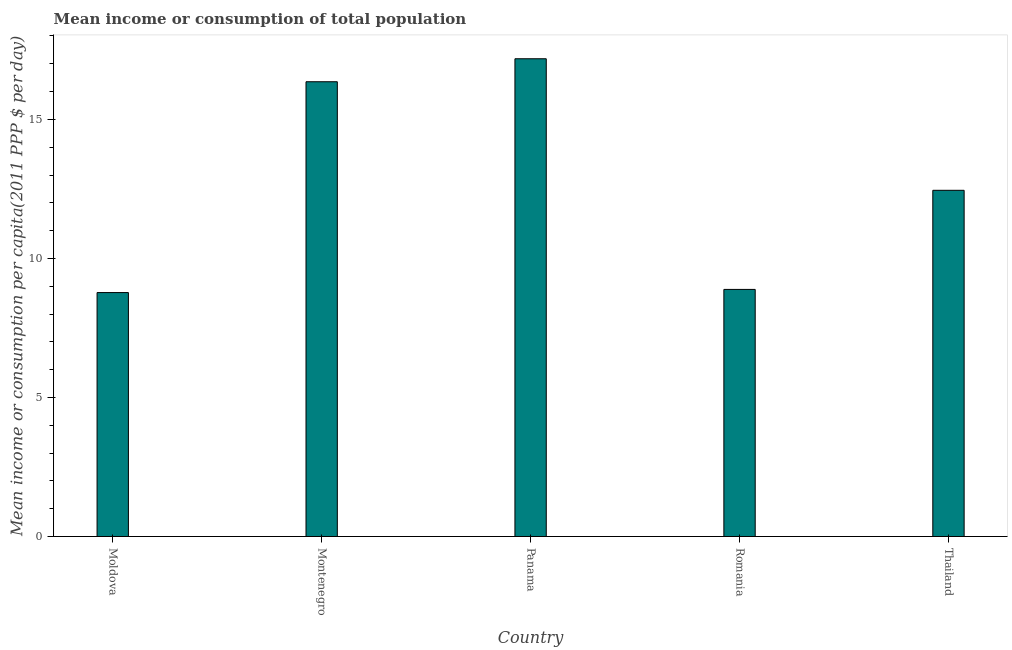Does the graph contain any zero values?
Your response must be concise. No. What is the title of the graph?
Your response must be concise. Mean income or consumption of total population. What is the label or title of the X-axis?
Offer a very short reply. Country. What is the label or title of the Y-axis?
Offer a terse response. Mean income or consumption per capita(2011 PPP $ per day). What is the mean income or consumption in Montenegro?
Give a very brief answer. 16.35. Across all countries, what is the maximum mean income or consumption?
Your answer should be very brief. 17.18. Across all countries, what is the minimum mean income or consumption?
Provide a succinct answer. 8.77. In which country was the mean income or consumption maximum?
Give a very brief answer. Panama. In which country was the mean income or consumption minimum?
Ensure brevity in your answer.  Moldova. What is the sum of the mean income or consumption?
Provide a succinct answer. 63.65. What is the difference between the mean income or consumption in Panama and Romania?
Make the answer very short. 8.29. What is the average mean income or consumption per country?
Give a very brief answer. 12.73. What is the median mean income or consumption?
Give a very brief answer. 12.45. In how many countries, is the mean income or consumption greater than 7 $?
Ensure brevity in your answer.  5. What is the ratio of the mean income or consumption in Moldova to that in Panama?
Your answer should be compact. 0.51. Is the difference between the mean income or consumption in Panama and Thailand greater than the difference between any two countries?
Give a very brief answer. No. What is the difference between the highest and the second highest mean income or consumption?
Ensure brevity in your answer.  0.83. What is the difference between the highest and the lowest mean income or consumption?
Offer a very short reply. 8.41. How many bars are there?
Provide a short and direct response. 5. Are all the bars in the graph horizontal?
Make the answer very short. No. How many countries are there in the graph?
Give a very brief answer. 5. Are the values on the major ticks of Y-axis written in scientific E-notation?
Offer a terse response. No. What is the Mean income or consumption per capita(2011 PPP $ per day) in Moldova?
Make the answer very short. 8.77. What is the Mean income or consumption per capita(2011 PPP $ per day) in Montenegro?
Give a very brief answer. 16.35. What is the Mean income or consumption per capita(2011 PPP $ per day) of Panama?
Provide a short and direct response. 17.18. What is the Mean income or consumption per capita(2011 PPP $ per day) of Romania?
Offer a terse response. 8.89. What is the Mean income or consumption per capita(2011 PPP $ per day) in Thailand?
Make the answer very short. 12.45. What is the difference between the Mean income or consumption per capita(2011 PPP $ per day) in Moldova and Montenegro?
Your answer should be compact. -7.58. What is the difference between the Mean income or consumption per capita(2011 PPP $ per day) in Moldova and Panama?
Make the answer very short. -8.41. What is the difference between the Mean income or consumption per capita(2011 PPP $ per day) in Moldova and Romania?
Offer a very short reply. -0.11. What is the difference between the Mean income or consumption per capita(2011 PPP $ per day) in Moldova and Thailand?
Offer a terse response. -3.68. What is the difference between the Mean income or consumption per capita(2011 PPP $ per day) in Montenegro and Panama?
Make the answer very short. -0.83. What is the difference between the Mean income or consumption per capita(2011 PPP $ per day) in Montenegro and Romania?
Provide a short and direct response. 7.47. What is the difference between the Mean income or consumption per capita(2011 PPP $ per day) in Montenegro and Thailand?
Your answer should be very brief. 3.9. What is the difference between the Mean income or consumption per capita(2011 PPP $ per day) in Panama and Romania?
Your response must be concise. 8.29. What is the difference between the Mean income or consumption per capita(2011 PPP $ per day) in Panama and Thailand?
Offer a terse response. 4.73. What is the difference between the Mean income or consumption per capita(2011 PPP $ per day) in Romania and Thailand?
Provide a short and direct response. -3.56. What is the ratio of the Mean income or consumption per capita(2011 PPP $ per day) in Moldova to that in Montenegro?
Offer a very short reply. 0.54. What is the ratio of the Mean income or consumption per capita(2011 PPP $ per day) in Moldova to that in Panama?
Offer a very short reply. 0.51. What is the ratio of the Mean income or consumption per capita(2011 PPP $ per day) in Moldova to that in Romania?
Ensure brevity in your answer.  0.99. What is the ratio of the Mean income or consumption per capita(2011 PPP $ per day) in Moldova to that in Thailand?
Provide a succinct answer. 0.7. What is the ratio of the Mean income or consumption per capita(2011 PPP $ per day) in Montenegro to that in Panama?
Your response must be concise. 0.95. What is the ratio of the Mean income or consumption per capita(2011 PPP $ per day) in Montenegro to that in Romania?
Provide a succinct answer. 1.84. What is the ratio of the Mean income or consumption per capita(2011 PPP $ per day) in Montenegro to that in Thailand?
Offer a terse response. 1.31. What is the ratio of the Mean income or consumption per capita(2011 PPP $ per day) in Panama to that in Romania?
Your answer should be compact. 1.93. What is the ratio of the Mean income or consumption per capita(2011 PPP $ per day) in Panama to that in Thailand?
Your answer should be very brief. 1.38. What is the ratio of the Mean income or consumption per capita(2011 PPP $ per day) in Romania to that in Thailand?
Your answer should be very brief. 0.71. 